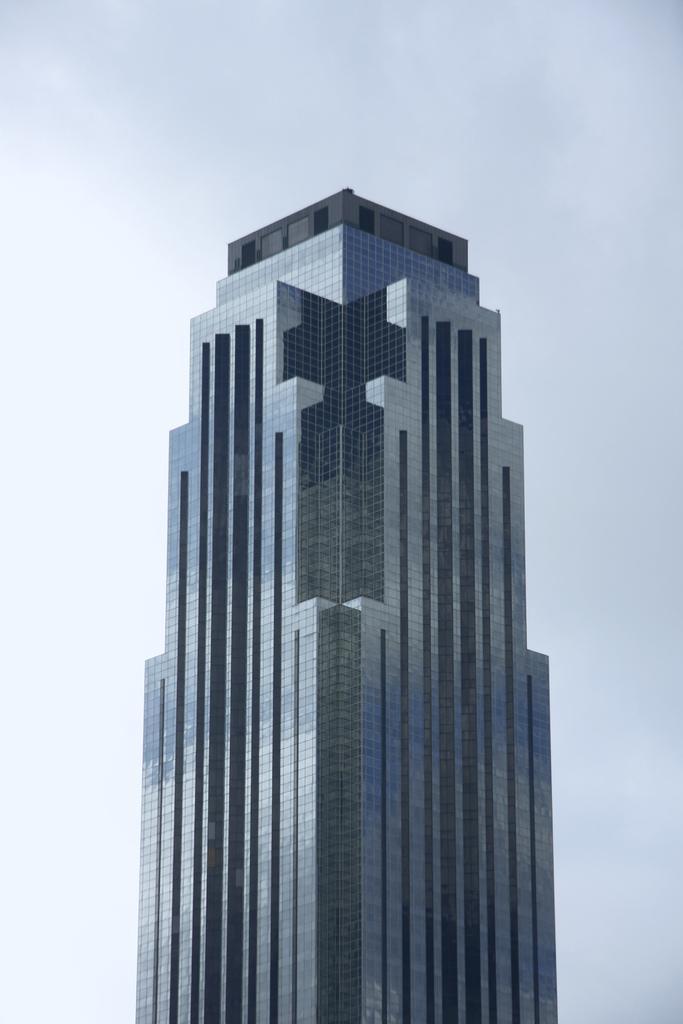In one or two sentences, can you explain what this image depicts? In this picture we can see the skyscraper. At the top we can see the sky and clouds. 